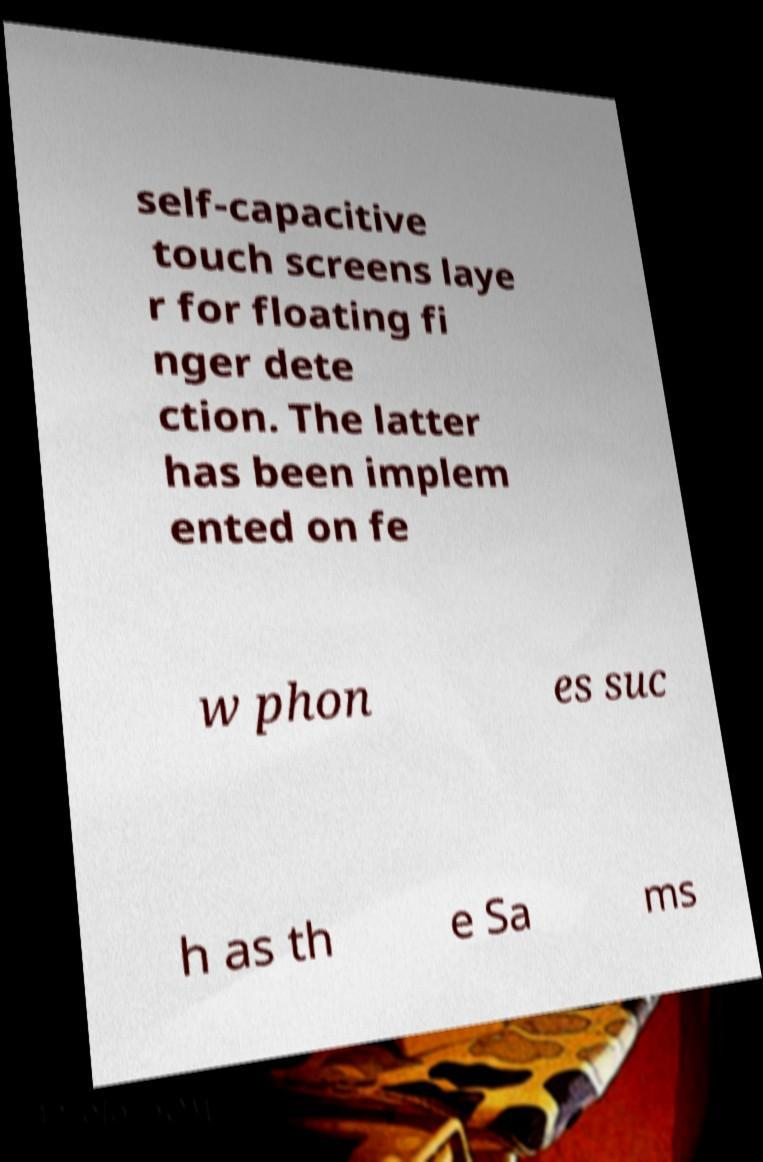Could you extract and type out the text from this image? self-capacitive touch screens laye r for floating fi nger dete ction. The latter has been implem ented on fe w phon es suc h as th e Sa ms 